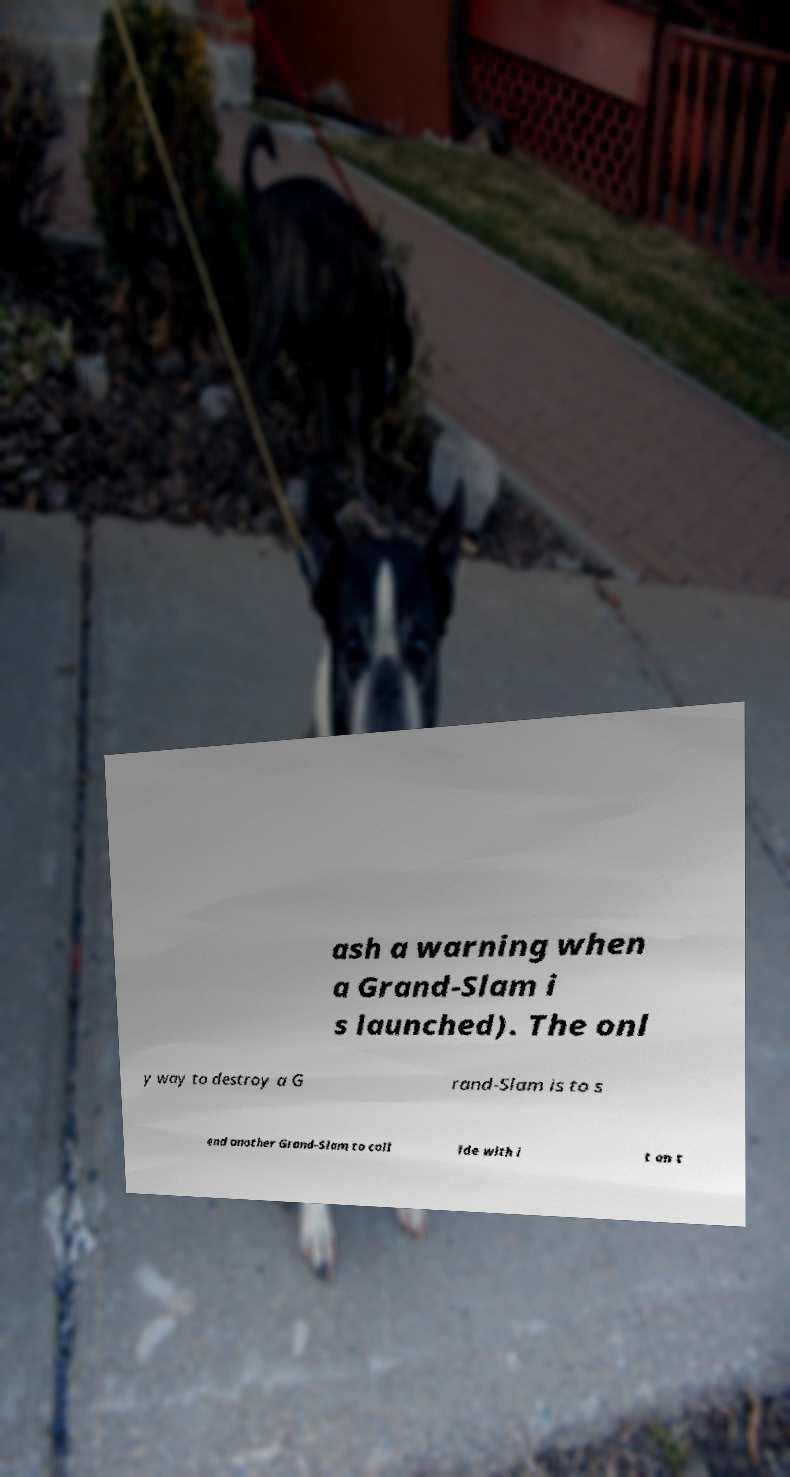Please identify and transcribe the text found in this image. ash a warning when a Grand-Slam i s launched). The onl y way to destroy a G rand-Slam is to s end another Grand-Slam to coll ide with i t on t 